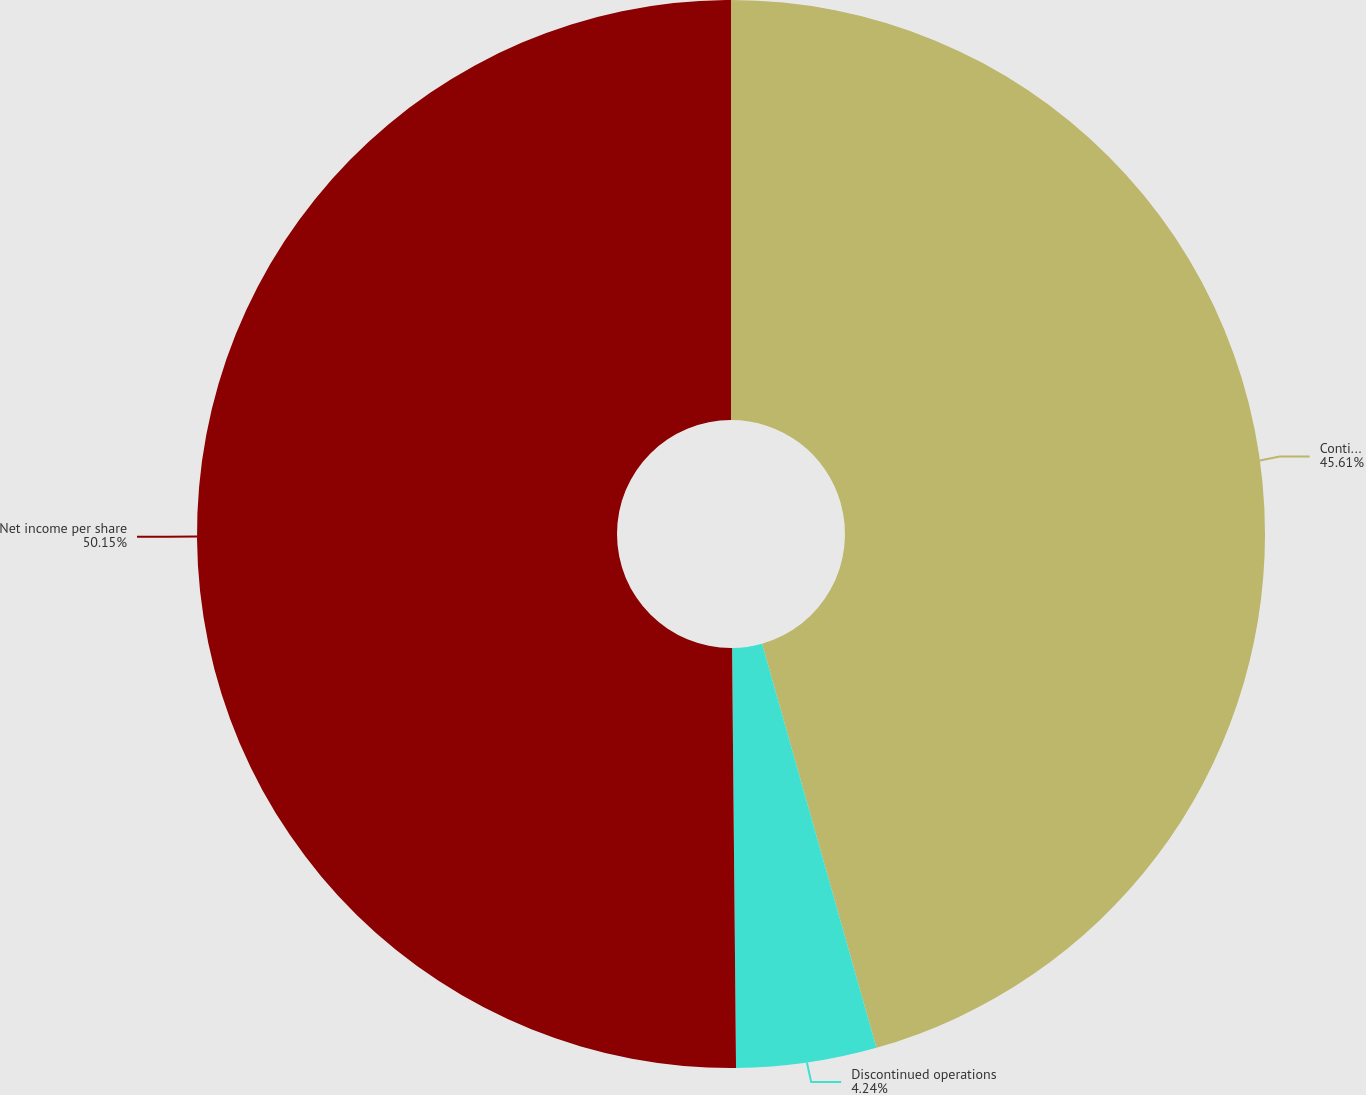<chart> <loc_0><loc_0><loc_500><loc_500><pie_chart><fcel>Continuing operations<fcel>Discontinued operations<fcel>Net income per share<nl><fcel>45.61%<fcel>4.24%<fcel>50.15%<nl></chart> 